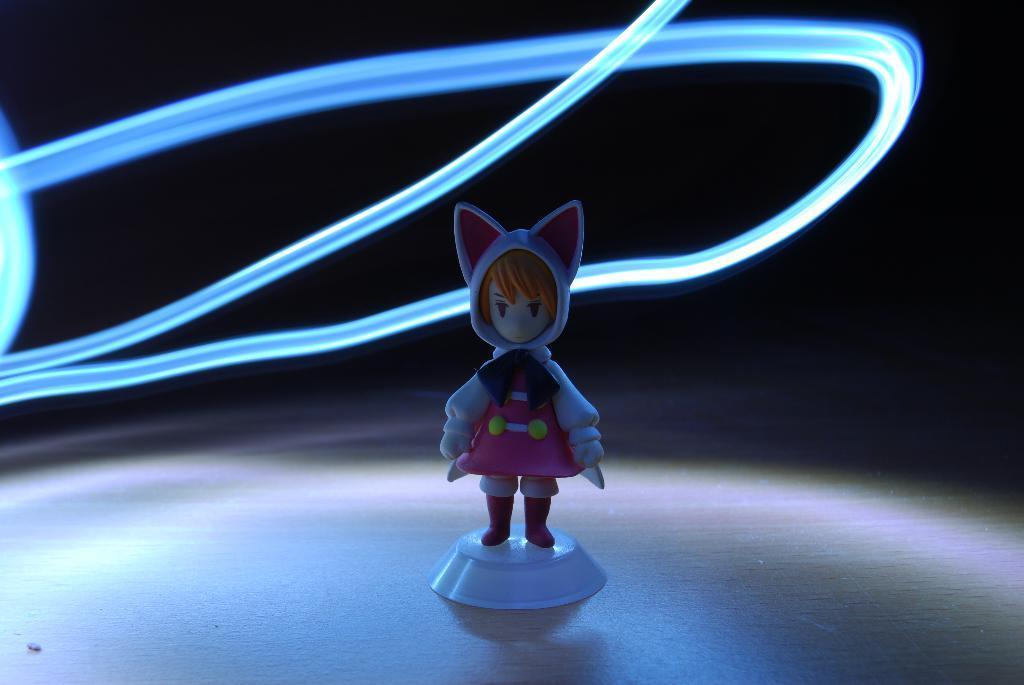Describe this image in one or two sentences. In the middle of the image there is a toy on the surface. In this image the background is dark and there are a few rope lights. 